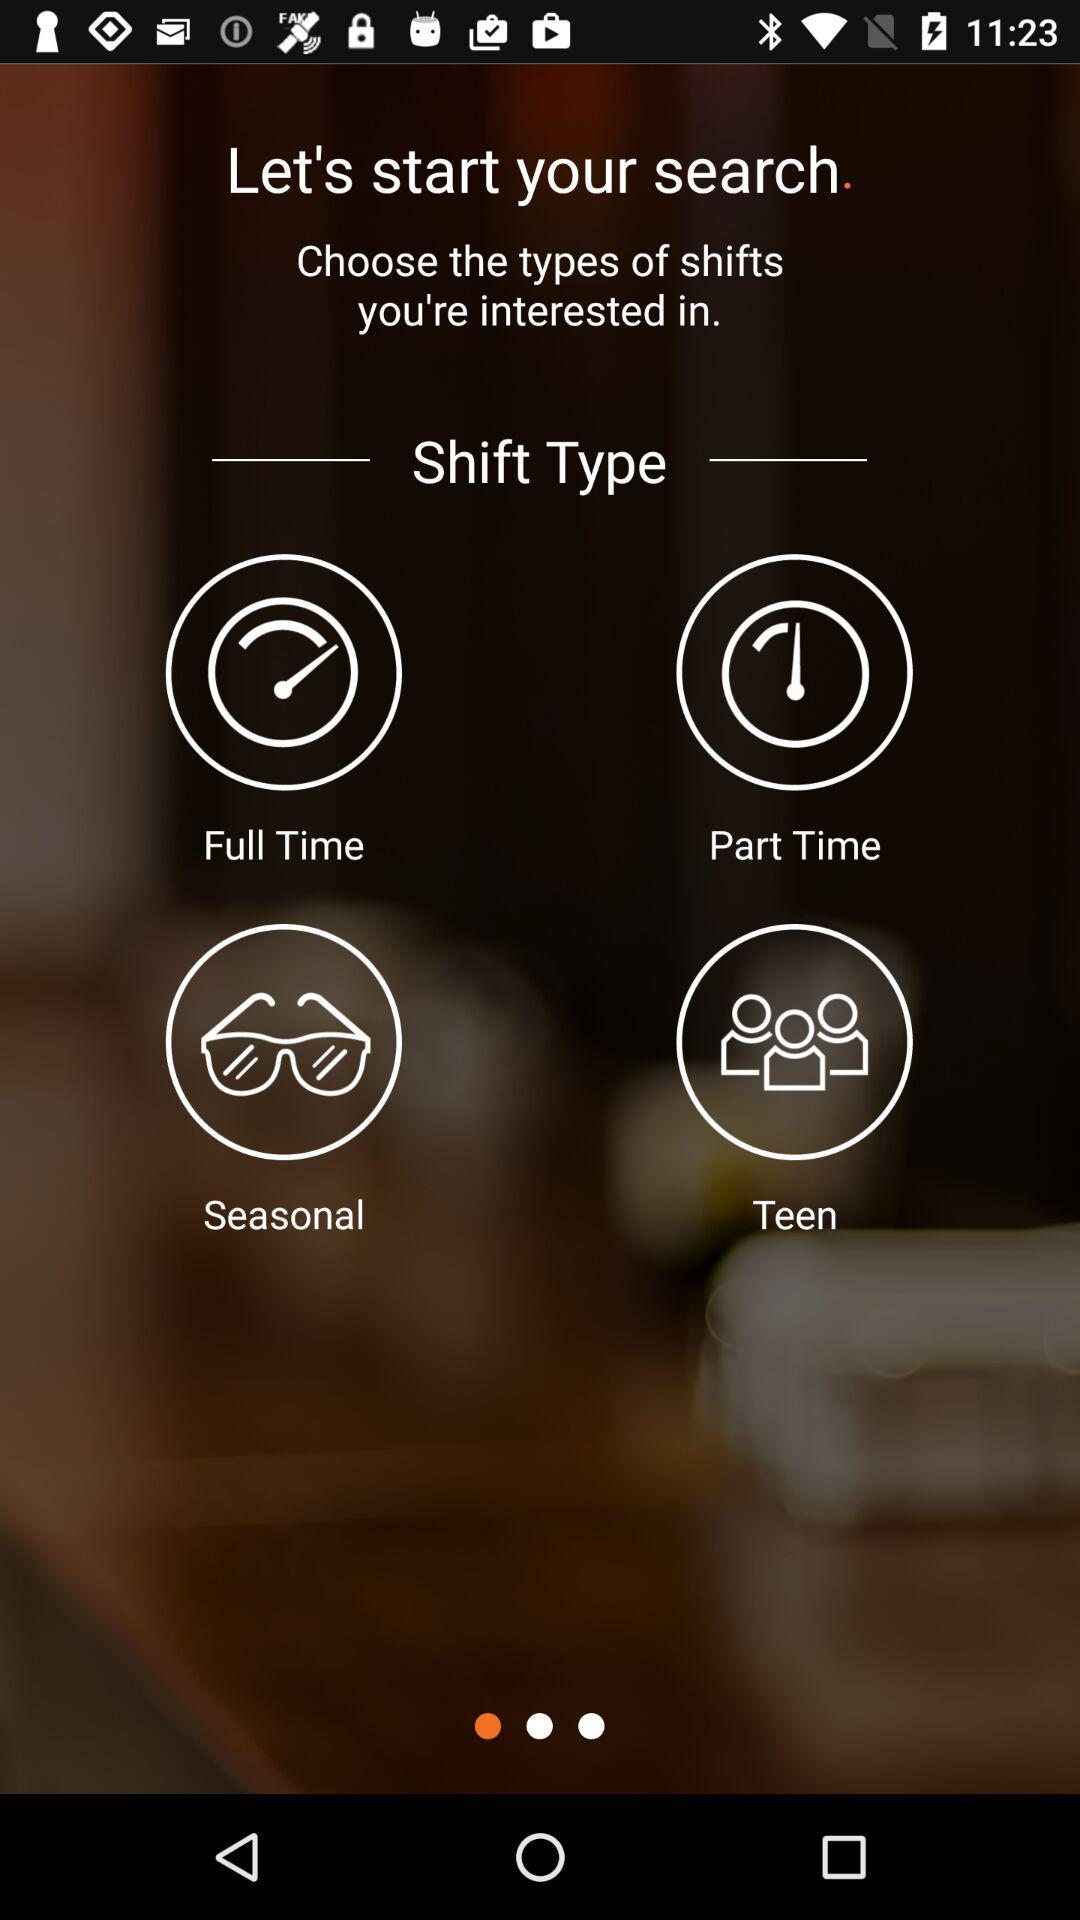What types of shifts are there? The types of shifts are "Full Time", "Part Time", "Seasonal" and "Teen". 